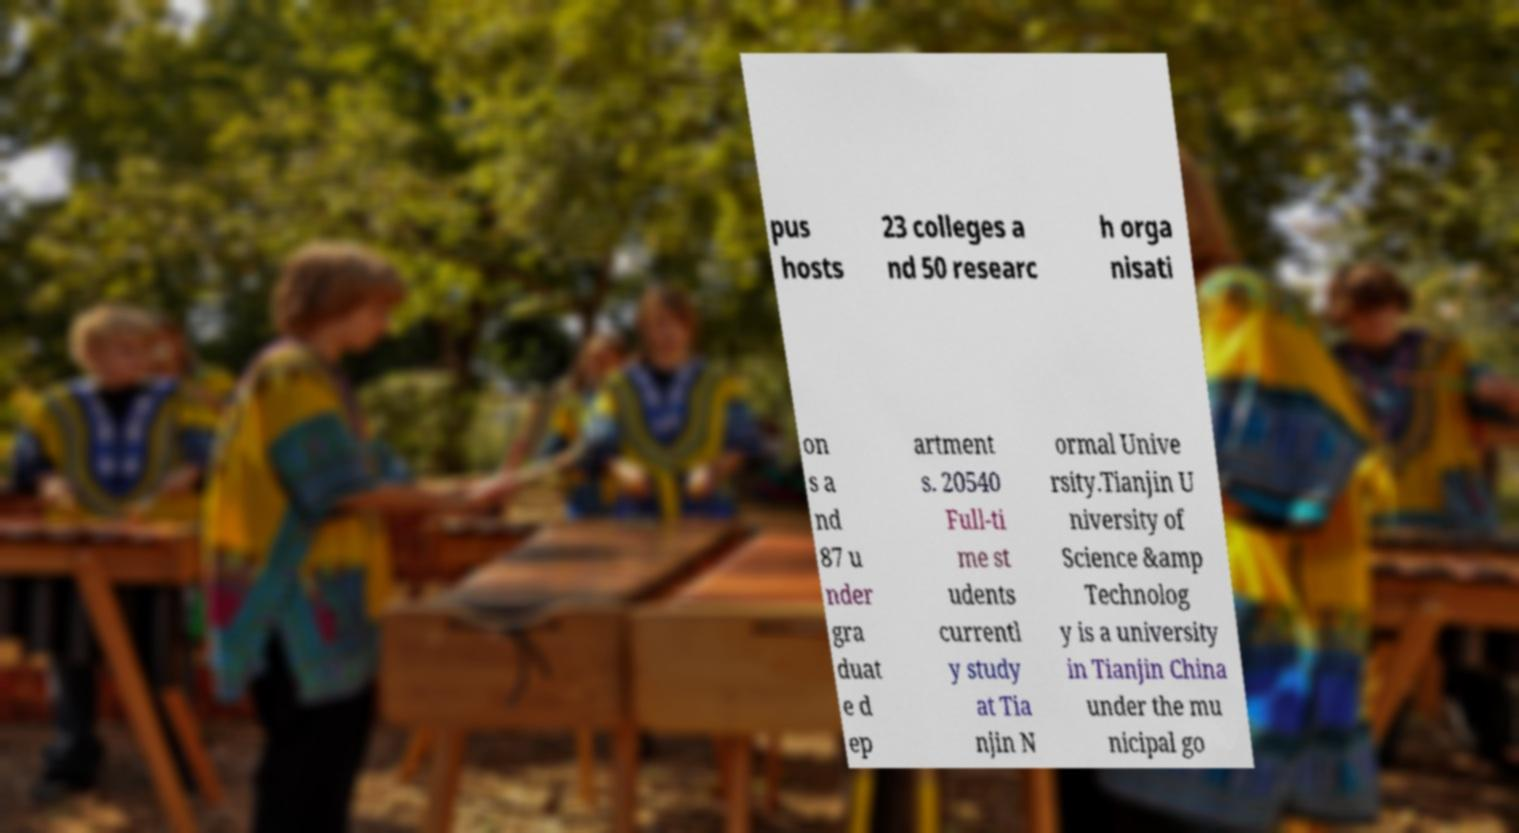Could you assist in decoding the text presented in this image and type it out clearly? pus hosts 23 colleges a nd 50 researc h orga nisati on s a nd 87 u nder gra duat e d ep artment s. 20540 Full-ti me st udents currentl y study at Tia njin N ormal Unive rsity.Tianjin U niversity of Science &amp Technolog y is a university in Tianjin China under the mu nicipal go 